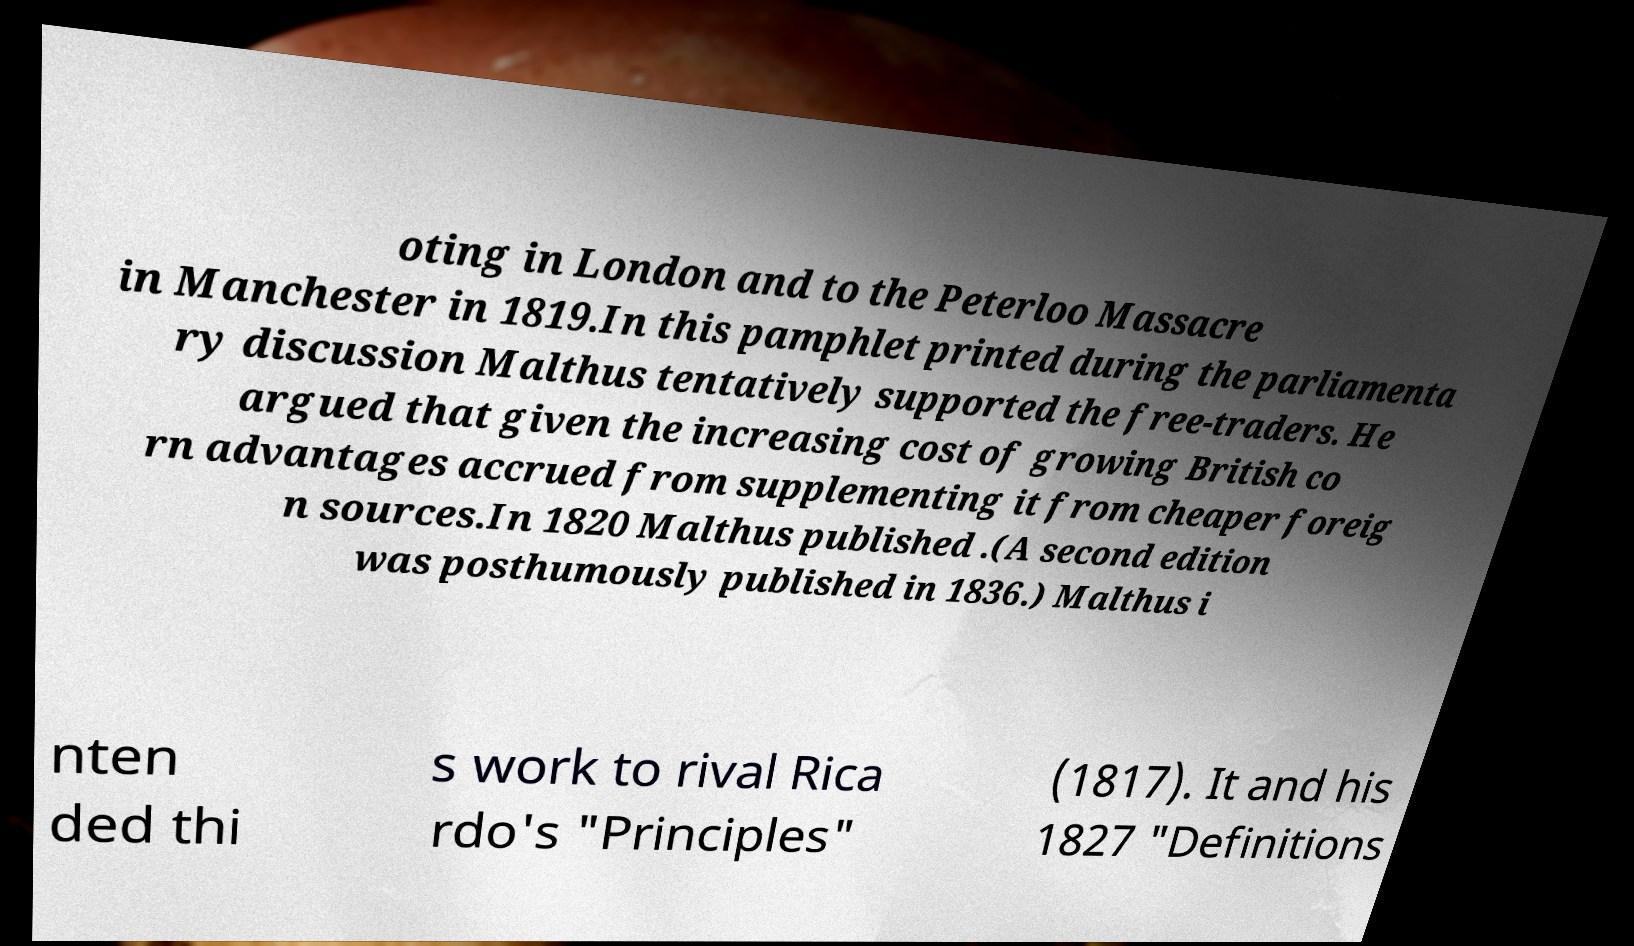Can you accurately transcribe the text from the provided image for me? oting in London and to the Peterloo Massacre in Manchester in 1819.In this pamphlet printed during the parliamenta ry discussion Malthus tentatively supported the free-traders. He argued that given the increasing cost of growing British co rn advantages accrued from supplementing it from cheaper foreig n sources.In 1820 Malthus published .(A second edition was posthumously published in 1836.) Malthus i nten ded thi s work to rival Rica rdo's "Principles" (1817). It and his 1827 "Definitions 